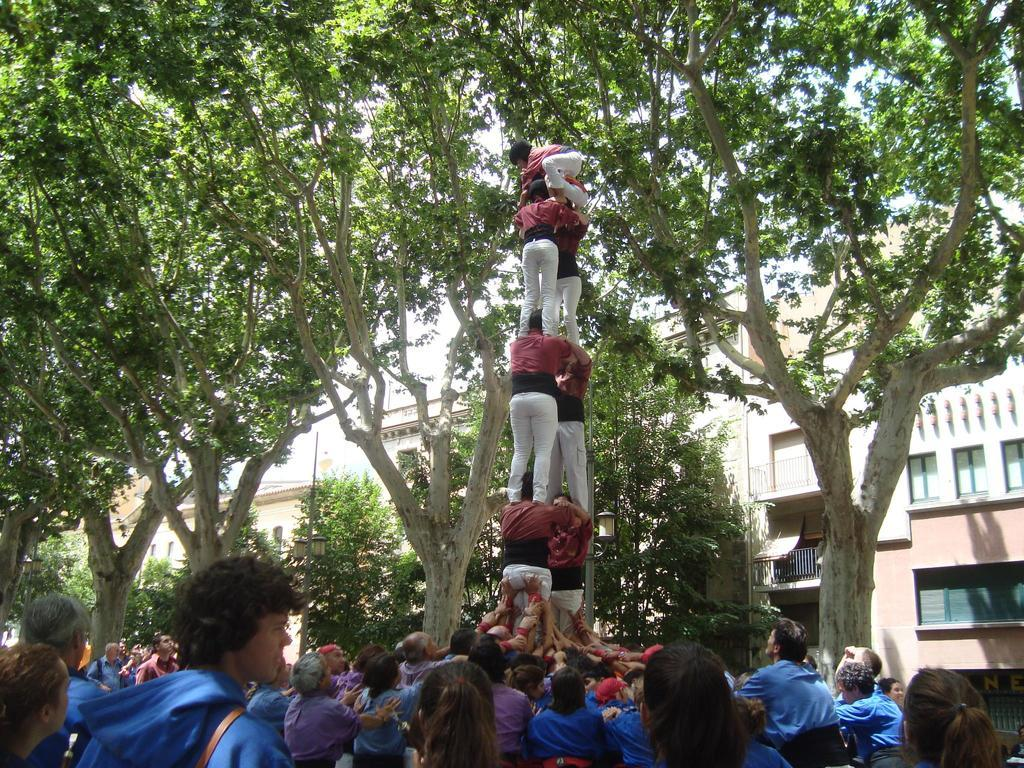What is the main subject in the front of the image? There is a group of persons in the front of the image. What can be seen in the background of the image? There are trees and buildings in the background of the image. What is the education level of the trail in the image? There is no trail present in the image, and therefore no education level can be determined. 